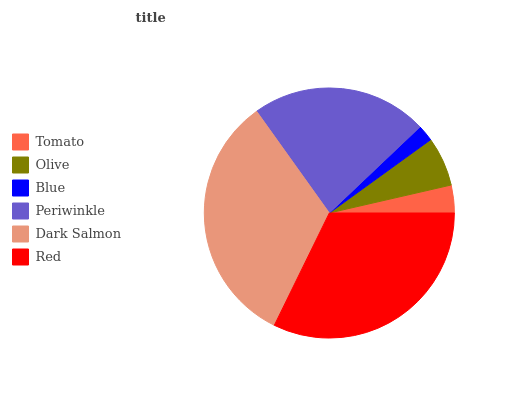Is Blue the minimum?
Answer yes or no. Yes. Is Dark Salmon the maximum?
Answer yes or no. Yes. Is Olive the minimum?
Answer yes or no. No. Is Olive the maximum?
Answer yes or no. No. Is Olive greater than Tomato?
Answer yes or no. Yes. Is Tomato less than Olive?
Answer yes or no. Yes. Is Tomato greater than Olive?
Answer yes or no. No. Is Olive less than Tomato?
Answer yes or no. No. Is Periwinkle the high median?
Answer yes or no. Yes. Is Olive the low median?
Answer yes or no. Yes. Is Red the high median?
Answer yes or no. No. Is Blue the low median?
Answer yes or no. No. 